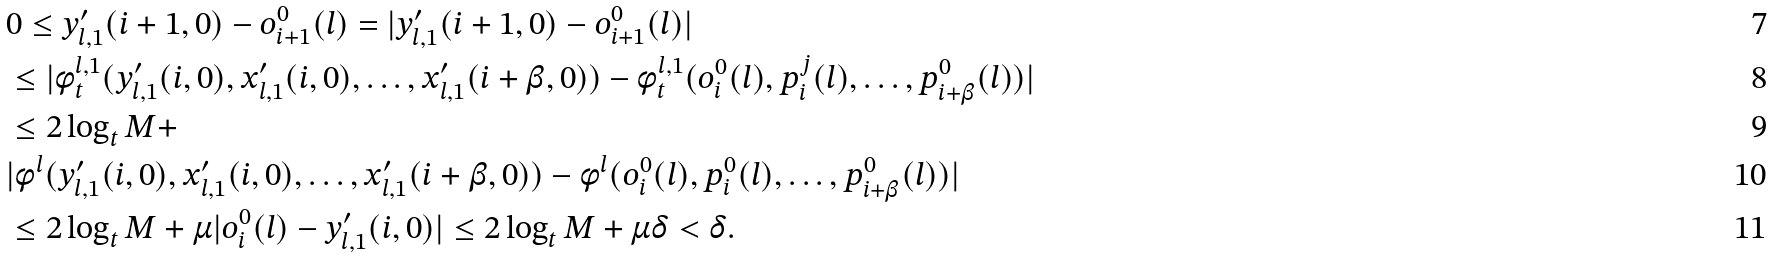Convert formula to latex. <formula><loc_0><loc_0><loc_500><loc_500>& 0 \leq y _ { l , 1 } ^ { \prime } ( i + 1 , 0 ) - o _ { i + 1 } ^ { 0 } ( l ) = | y _ { l , 1 } ^ { \prime } ( i + 1 , 0 ) - o _ { i + 1 } ^ { 0 } ( l ) | \\ & \leq | \phi _ { t } ^ { l , 1 } ( y _ { l , 1 } ^ { \prime } ( i , 0 ) , x _ { l , 1 } ^ { \prime } ( i , 0 ) , \dots , x _ { l , 1 } ^ { \prime } ( i + \beta , 0 ) ) - \phi _ { t } ^ { l , 1 } ( o _ { i } ^ { 0 } ( l ) , p _ { i } ^ { j } ( l ) , \dots , p _ { i + \beta } ^ { 0 } ( l ) ) | \\ & \leq 2 \log _ { t } M + \\ & | \phi ^ { l } ( y _ { l , 1 } ^ { \prime } ( i , 0 ) , x _ { l , 1 } ^ { \prime } ( i , 0 ) , \dots , x _ { l , 1 } ^ { \prime } ( i + \beta , 0 ) ) - \phi ^ { l } ( o _ { i } ^ { 0 } ( l ) , p _ { i } ^ { 0 } ( l ) , \dots , p _ { i + \beta } ^ { 0 } ( l ) ) | \\ & \leq 2 \log _ { t } M + \mu | o _ { i } ^ { 0 } ( l ) - y _ { l , 1 } ^ { \prime } ( i , 0 ) | \leq 2 \log _ { t } M + \mu \delta < \delta .</formula> 